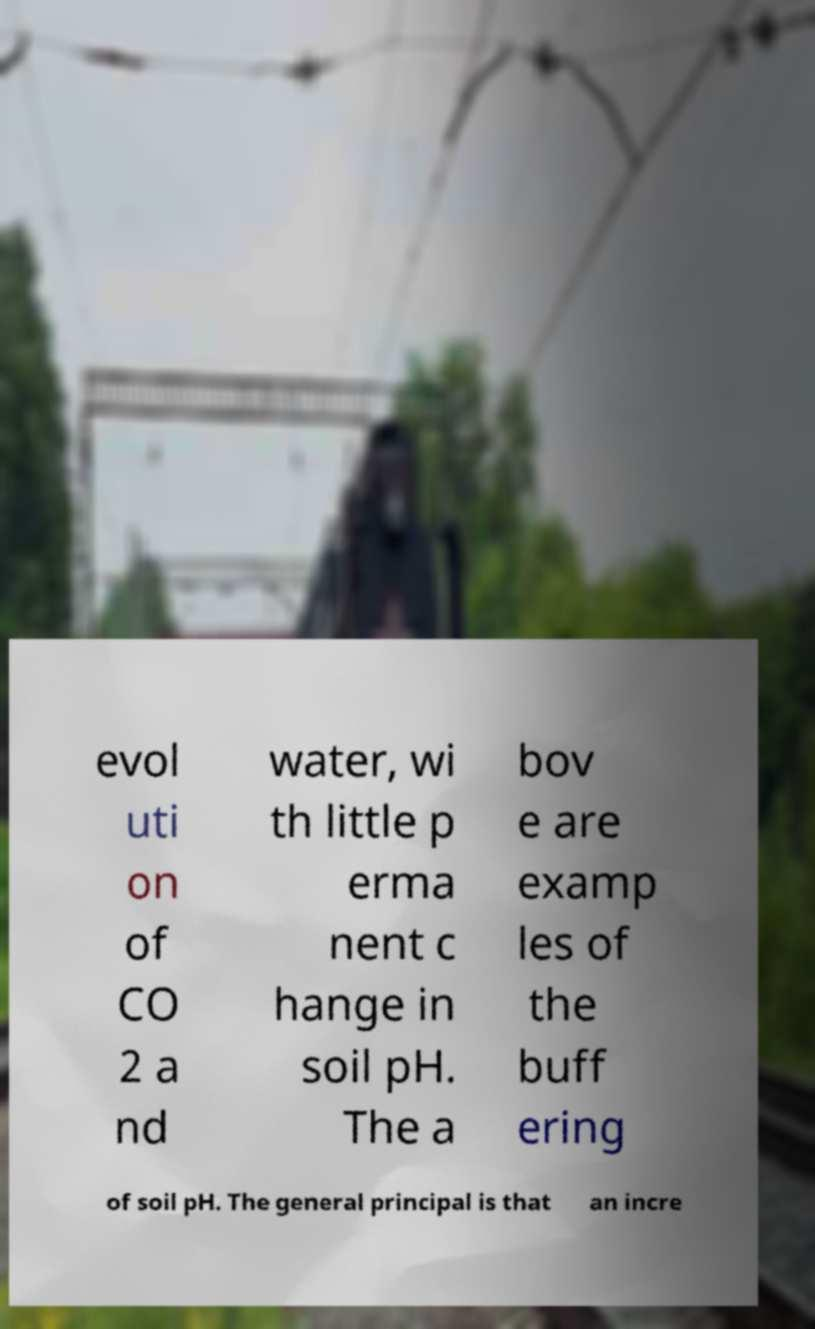Can you read and provide the text displayed in the image?This photo seems to have some interesting text. Can you extract and type it out for me? evol uti on of CO 2 a nd water, wi th little p erma nent c hange in soil pH. The a bov e are examp les of the buff ering of soil pH. The general principal is that an incre 